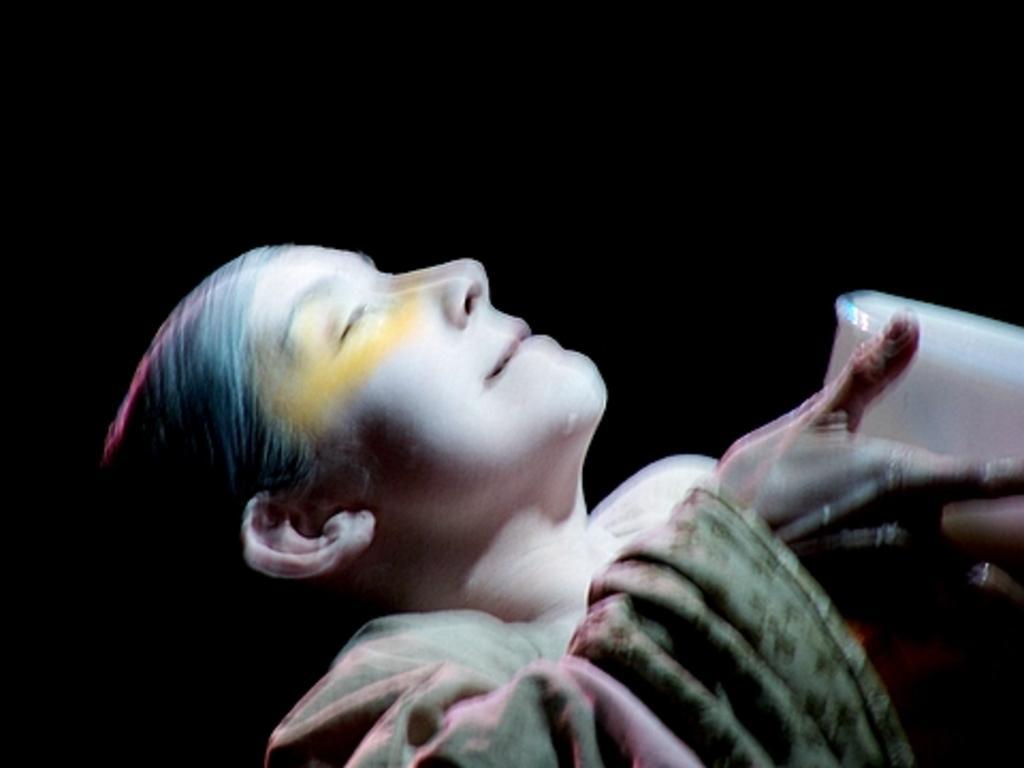Could you give a brief overview of what you see in this image? In this image we can see a person holding some box in her hands. 